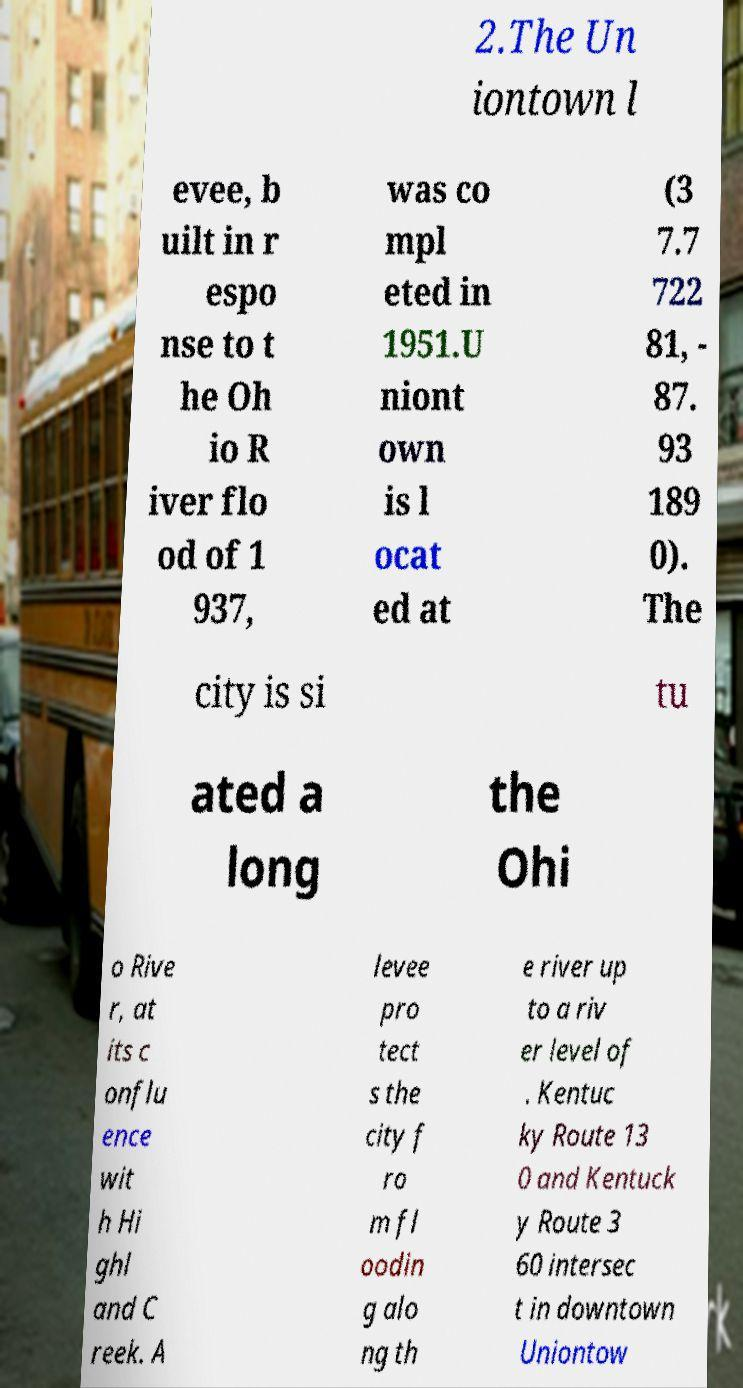What messages or text are displayed in this image? I need them in a readable, typed format. 2.The Un iontown l evee, b uilt in r espo nse to t he Oh io R iver flo od of 1 937, was co mpl eted in 1951.U niont own is l ocat ed at (3 7.7 722 81, - 87. 93 189 0). The city is si tu ated a long the Ohi o Rive r, at its c onflu ence wit h Hi ghl and C reek. A levee pro tect s the city f ro m fl oodin g alo ng th e river up to a riv er level of . Kentuc ky Route 13 0 and Kentuck y Route 3 60 intersec t in downtown Uniontow 